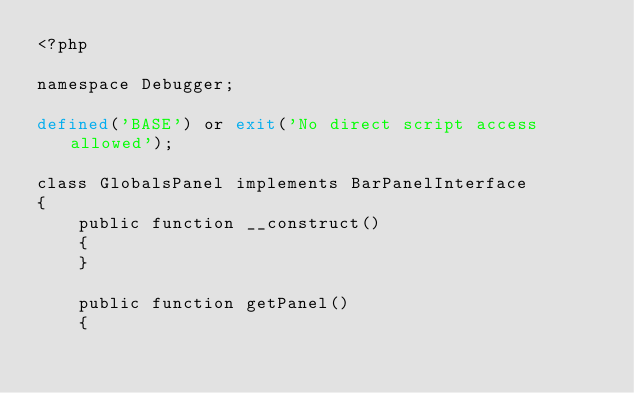Convert code to text. <code><loc_0><loc_0><loc_500><loc_500><_PHP_><?php

namespace Debugger;

defined('BASE') or exit('No direct script access allowed');

class GlobalsPanel implements BarPanelInterface
{
    public function __construct()
    {
    }

    public function getPanel()
    {</code> 